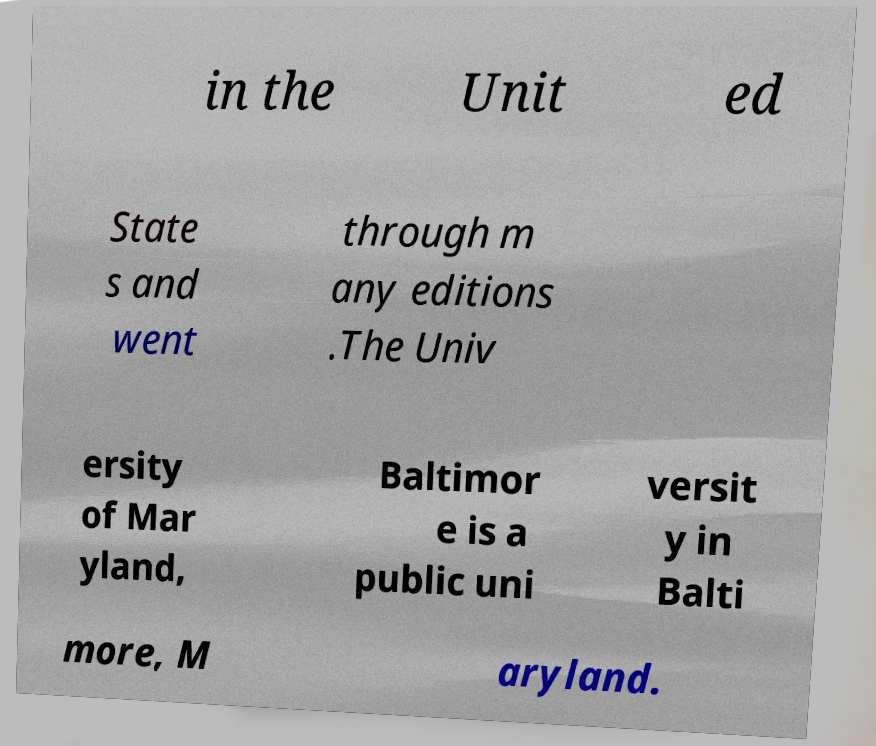Could you assist in decoding the text presented in this image and type it out clearly? in the Unit ed State s and went through m any editions .The Univ ersity of Mar yland, Baltimor e is a public uni versit y in Balti more, M aryland. 